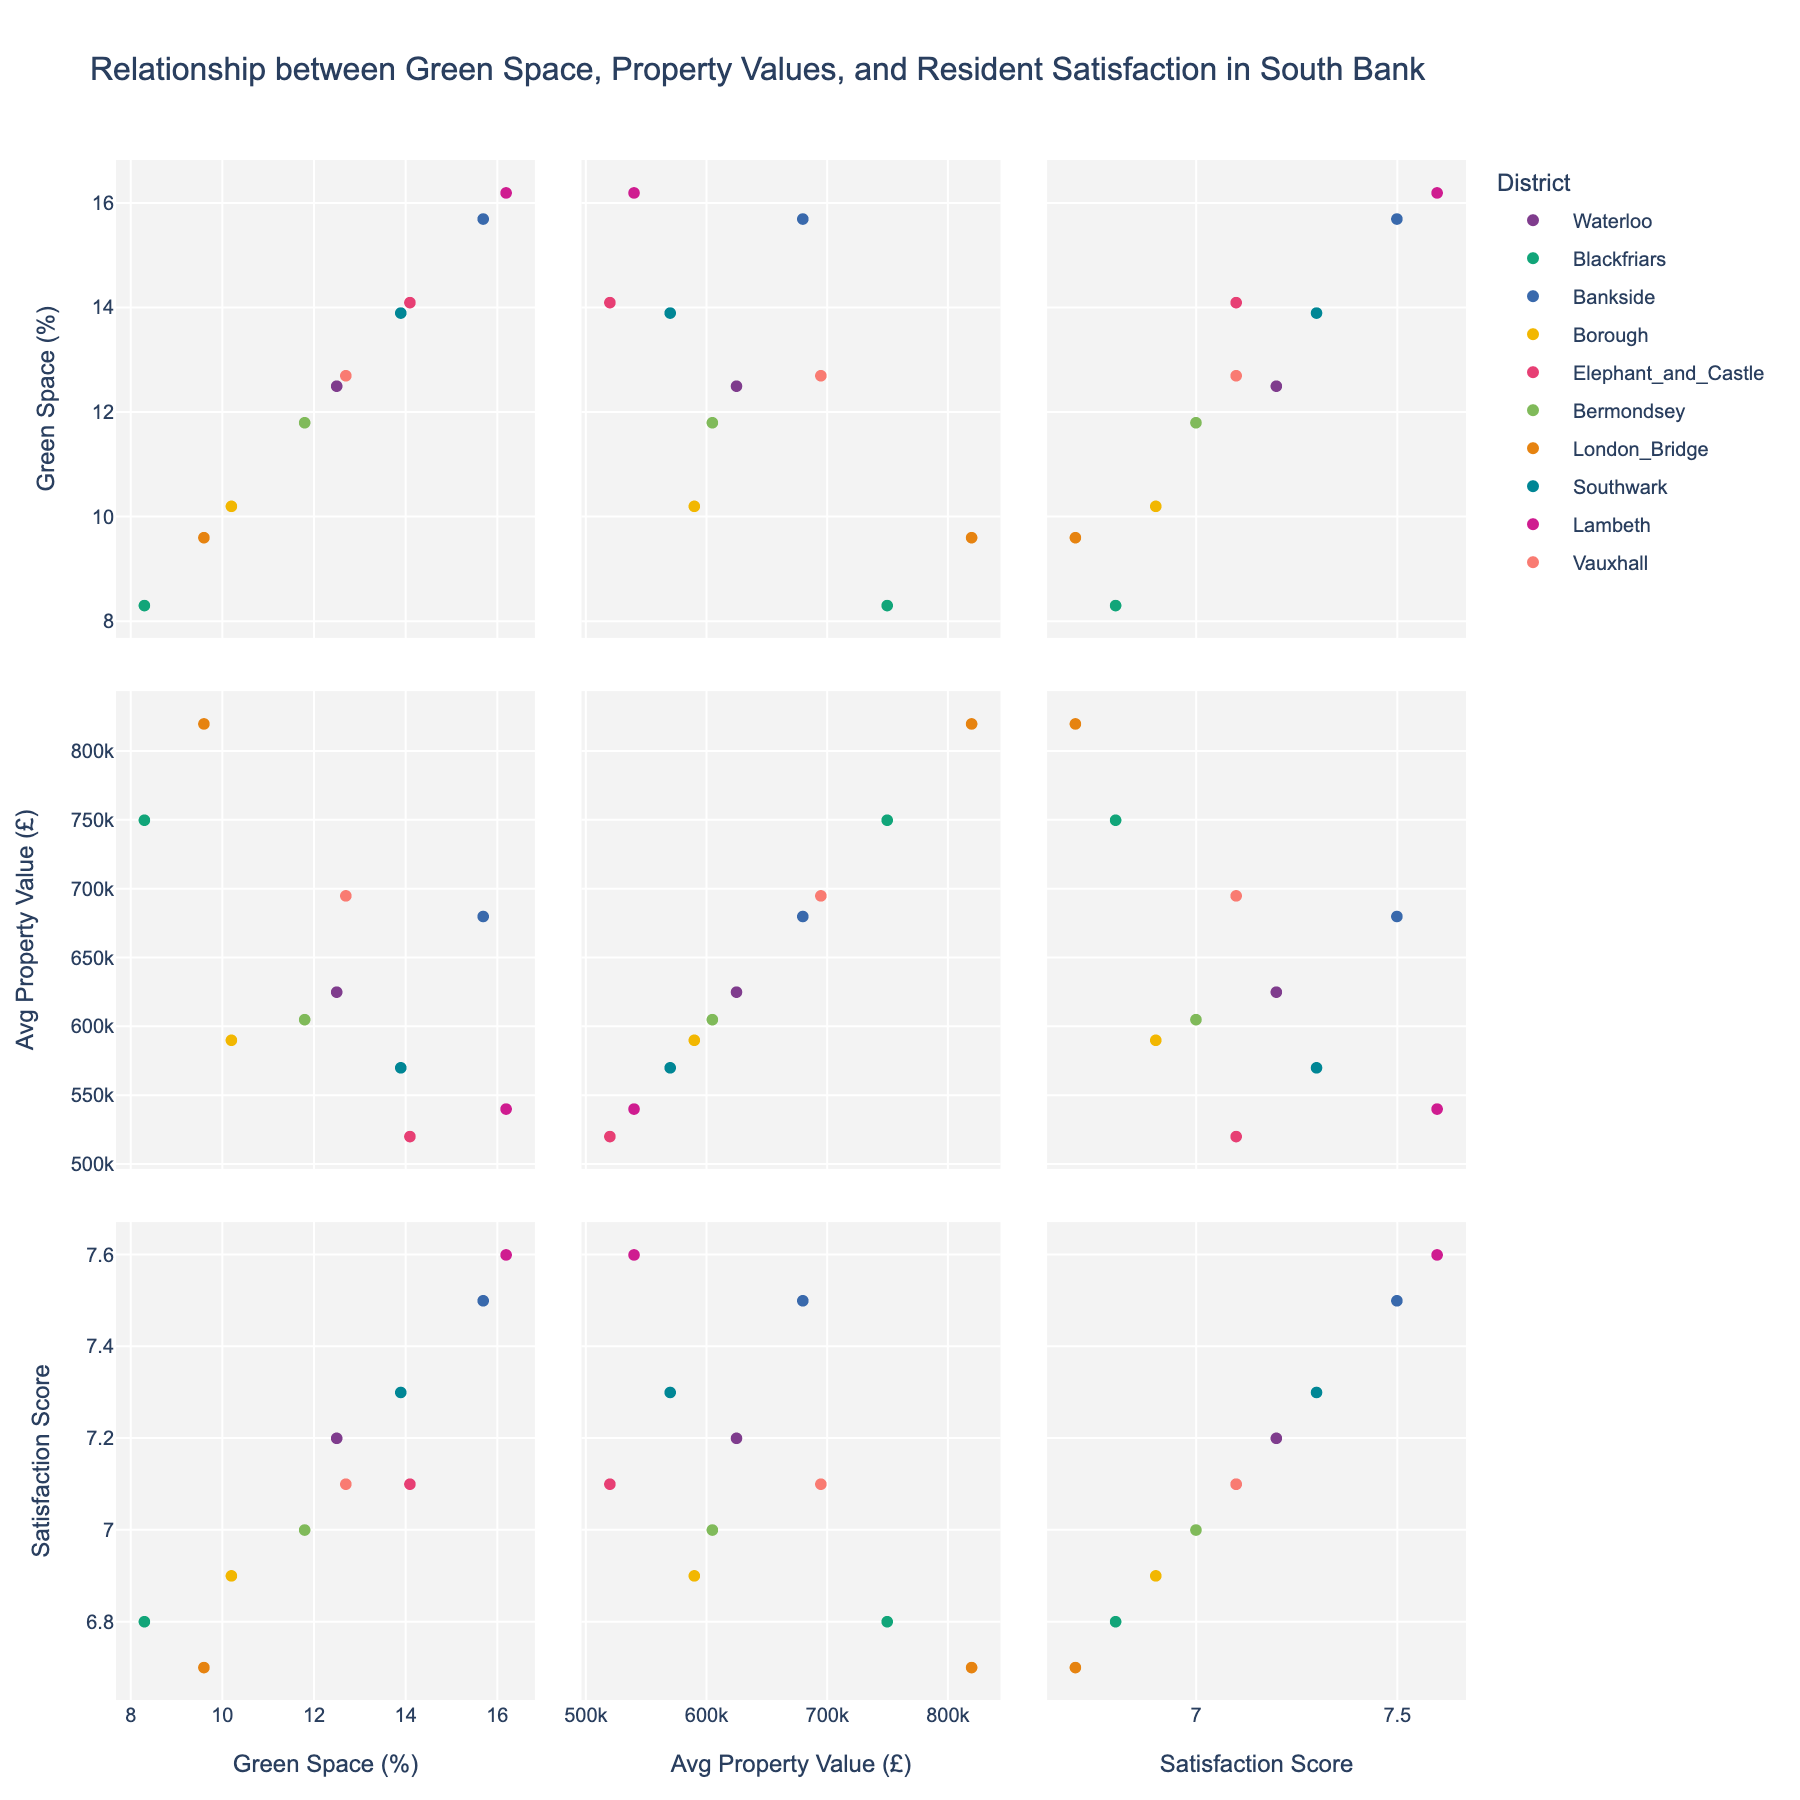What is the title of the figure? The title of the figure is located at the top center part of the visual. It states the purpose of the plot.
Answer: Distribution of Educational Attainment in Our Village What percentage of adults have no formal education? Refer to the pie chart on the left, which shows the breakdown of different education levels. The segment labeled "No Formal Education" indicates its percentage.
Answer: 25% What is the combined percentage of adults who have received secondary or tertiary education? Look at the percentages listed for Secondary Education and Tertiary Education on the pie chart on the left. Add these two percentages together to get the combined value. 28% + 10% = 38%
Answer: 38% Which education level has the highest percentage? Examine the pie chart on the left. Identify the segment with the largest portion and corresponding percentage.
Answer: Primary Education How much more prevalent is primary education compared to vocational training? Identify the percentages for both Primary Education and Vocational Training from the pie chart on the left. Subtract the percentage of Vocational Training from Primary Education. 35% - 2% = 33%
Answer: 33% What percentage of adults have some formal education? Look at the pie chart on the right, which dichotomizes the population into "Educated" and "No Formal Education." The "Educated" segment shows the percentage of adults with any formal education.
Answer: 75% Which pie chart shows the detailed breakdown of education levels? There are two pie charts; one shows detailed education levels while the other shows a broader classification. Identify the chart with specific labels such as Primary, Secondary, etc.
Answer: The pie chart on the left Are there more adults with primary education or secondary education? Compare the segments for Primary Education and Secondary Education on the left pie chart. Identify which segment has a larger percentage.
Answer: Primary Education If 10 more adults attain tertiary education, which education level percentages would decrease assuming the total number of adults remains the same? More adults attaining tertiary education while the total remains the same means other segments must decrease. Identify those segments.
Answer: Other segments like No Formal Education, Primary, Secondary, and Vocational Training would decrease Is the percentage of adults with vocational training greater or less than those with tertiary education? Compare the percentages listed for Vocational Training and Tertiary Education in the left pie chart. Determine which percentage is larger.
Answer: Less 